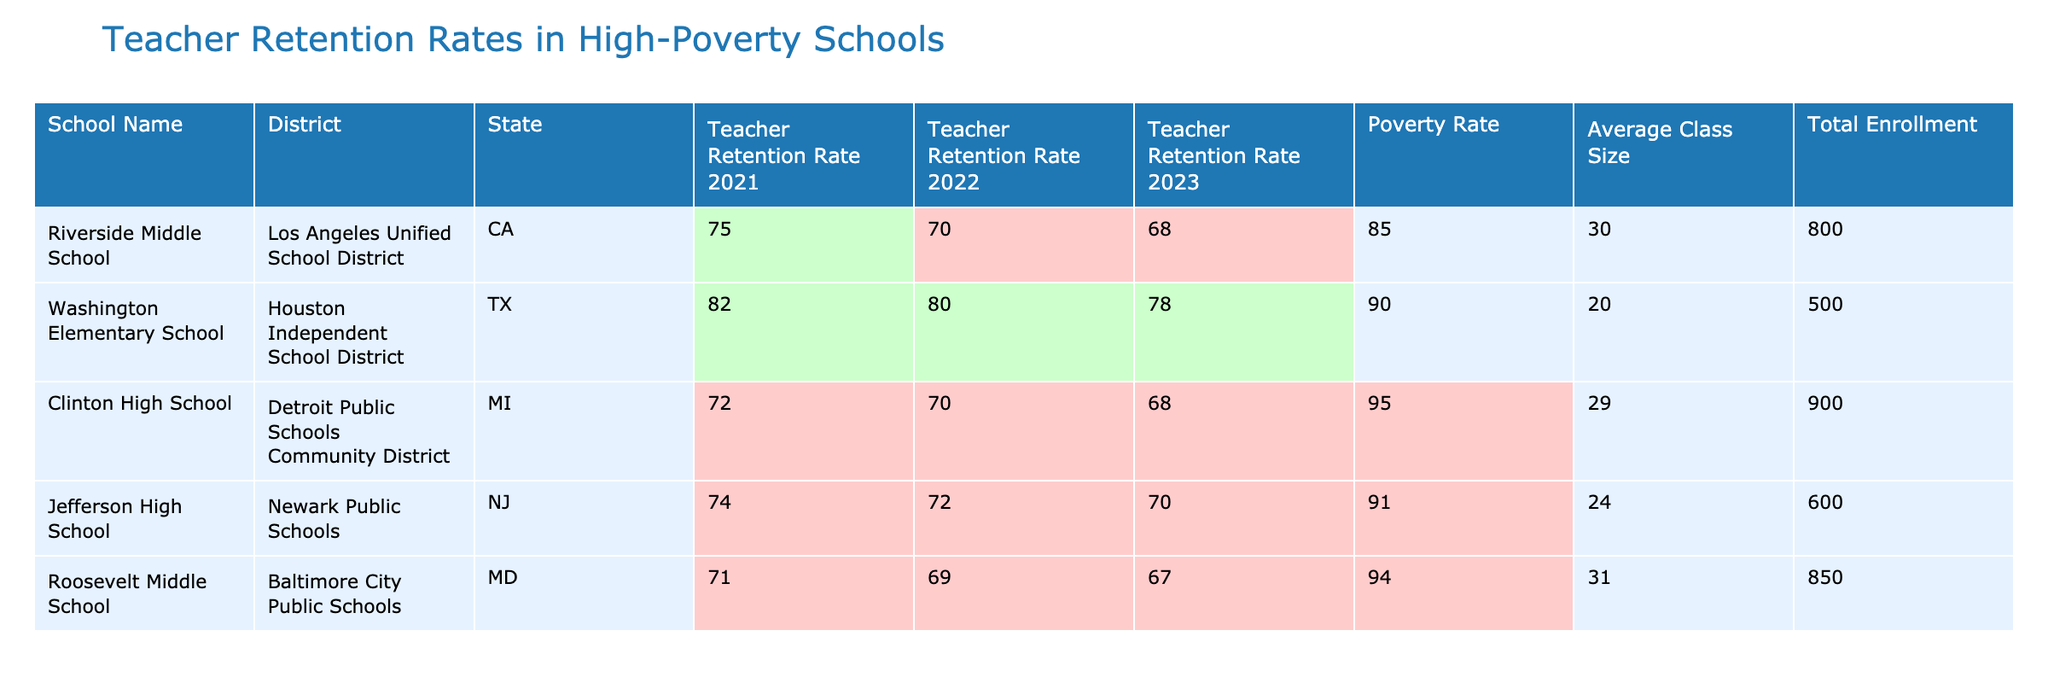What is the Teacher Retention Rate for Washington Elementary School in 2023? The table shows the Teacher Retention Rate for Washington Elementary School in 2023 is listed under the respective column for that year. It is shown as 78%.
Answer: 78% Which school has the highest Teacher Retention Rate in 2021? By inspecting the Teacher Retention Rates for 2021, the maximum value among the listed schools corresponds to Washington Elementary School, which has a rate of 82%.
Answer: Washington Elementary School What is the average Teacher Retention Rate in 2022 for all schools listed? The Teacher Retention Rates for 2022 are 80%, 70%, 70%, 72%, and 69%. Adding these gives 361%. Dividing by the number of schools (5) results in an average of 72.2%.
Answer: 72.2% Is the Teacher Retention Rate for Clinton High School in 2023 below the overall average for that year? The rate for Clinton High School in 2023 is 68%. The overall Teacher Retention Rates for 2023 are 68%, 78%, 68%, 70%, and 67%. The average is 70.2%, which is higher than 68%. Therefore, Clinton's rate is below the average.
Answer: Yes How does the Teacher Retention Rate trend from 2021 to 2023 for Riverside Middle School? Riverside Middle School's retention rates are 75% in 2021, 70% in 2022, and 68% in 2023. Observing these numbers indicates a decrease from 75% to 70% to 68%, showing a declining trend over the three years.
Answer: Declining trend Which two schools have the highest and lowest Poverty Rates and what are those rates? By analyzing the Poverty Rates listed, Clinton High School has the highest at 95%, while Washington Elementary School has the lowest at 90%. The difference showcases stark contrasts in poverty levels within the schools.
Answer: Highest: Clinton High School (95%), Lowest: Washington Elementary School (90%) If we consider a threshold of a 75% Teacher Retention Rate, how many schools fall below this threshold in 2023? In 2023, the retention rates are 68%, 78%, 68%, 70%, and 67%. Three of these rates (68%, 68%, and 67%) are below 75%. Therefore, the count of schools falling below this threshold is 3.
Answer: 3 What is the ratio of the average class size to the Highest Teacher Retention Rate in 2022? The average class size across schools is (30 + 20 + 29 + 24 + 31) / 5 = 26.8. The highest Teacher Retention Rate for 2022 is 80%. The ratio of average class size to Teacher Retention Rate is 26.8:80, which simplifies to approximately 0.335.
Answer: 0.335 Are all schools listed retaining more than 70% of their teachers in 2022? The Teacher Retention Rates for 2022 are 80%, 70%, 70%, 72%, and 69%. Since one school (Roosevelt Middle School) retains only 69%, it indicates that not all schools exceed the 70% threshold.
Answer: No 